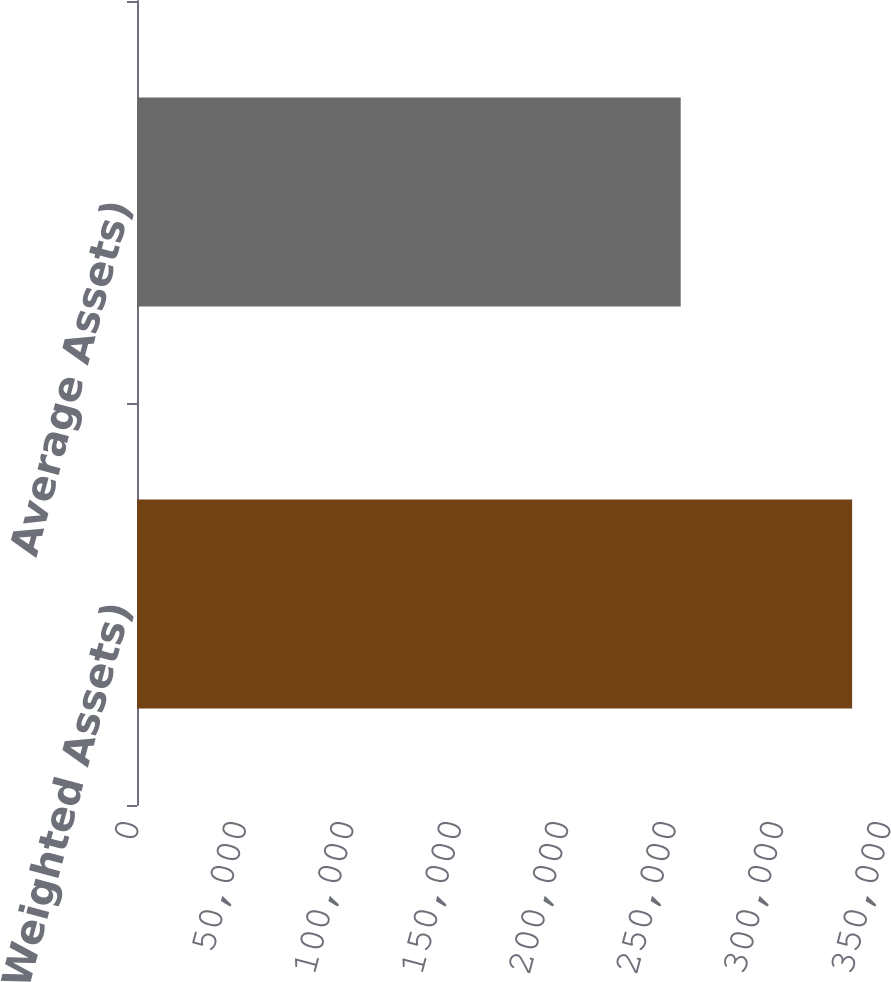Convert chart. <chart><loc_0><loc_0><loc_500><loc_500><bar_chart><fcel>Risk-Weighted Assets)<fcel>Average Assets)<nl><fcel>332832<fcel>253048<nl></chart> 